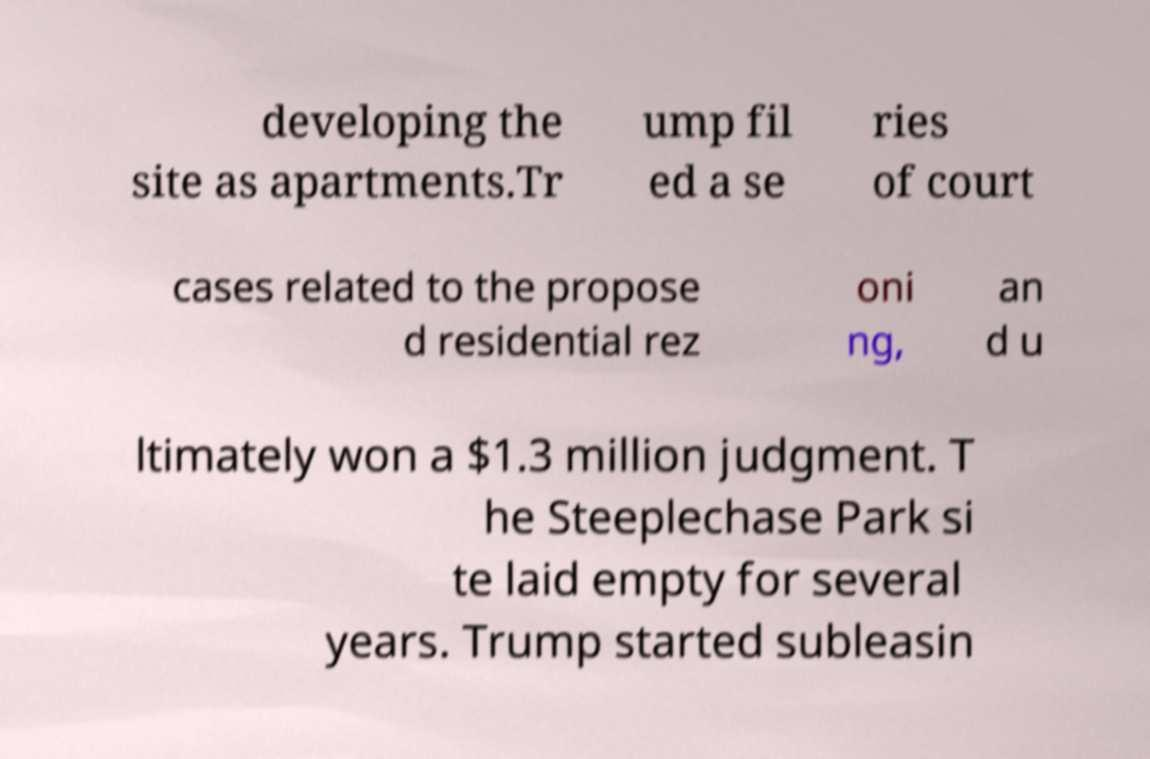What messages or text are displayed in this image? I need them in a readable, typed format. developing the site as apartments.Tr ump fil ed a se ries of court cases related to the propose d residential rez oni ng, an d u ltimately won a $1.3 million judgment. T he Steeplechase Park si te laid empty for several years. Trump started subleasin 